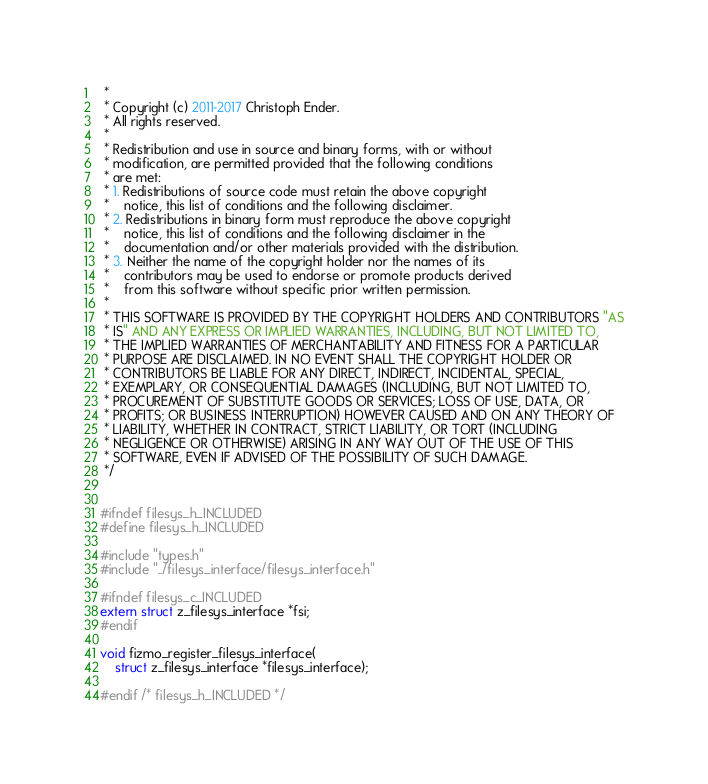Convert code to text. <code><loc_0><loc_0><loc_500><loc_500><_C_> *
 * Copyright (c) 2011-2017 Christoph Ender.
 * All rights reserved.
 *
 * Redistribution and use in source and binary forms, with or without
 * modification, are permitted provided that the following conditions
 * are met:
 * 1. Redistributions of source code must retain the above copyright
 *    notice, this list of conditions and the following disclaimer.
 * 2. Redistributions in binary form must reproduce the above copyright
 *    notice, this list of conditions and the following disclaimer in the
 *    documentation and/or other materials provided with the distribution.
 * 3. Neither the name of the copyright holder nor the names of its
 *    contributors may be used to endorse or promote products derived
 *    from this software without specific prior written permission.
 * 
 * THIS SOFTWARE IS PROVIDED BY THE COPYRIGHT HOLDERS AND CONTRIBUTORS "AS
 * IS" AND ANY EXPRESS OR IMPLIED WARRANTIES, INCLUDING, BUT NOT LIMITED TO,
 * THE IMPLIED WARRANTIES OF MERCHANTABILITY AND FITNESS FOR A PARTICULAR
 * PURPOSE ARE DISCLAIMED. IN NO EVENT SHALL THE COPYRIGHT HOLDER OR
 * CONTRIBUTORS BE LIABLE FOR ANY DIRECT, INDIRECT, INCIDENTAL, SPECIAL,
 * EXEMPLARY, OR CONSEQUENTIAL DAMAGES (INCLUDING, BUT NOT LIMITED TO,
 * PROCUREMENT OF SUBSTITUTE GOODS OR SERVICES; LOSS OF USE, DATA, OR
 * PROFITS; OR BUSINESS INTERRUPTION) HOWEVER CAUSED AND ON ANY THEORY OF
 * LIABILITY, WHETHER IN CONTRACT, STRICT LIABILITY, OR TORT (INCLUDING
 * NEGLIGENCE OR OTHERWISE) ARISING IN ANY WAY OUT OF THE USE OF THIS
 * SOFTWARE, EVEN IF ADVISED OF THE POSSIBILITY OF SUCH DAMAGE.
 */


#ifndef filesys_h_INCLUDED 
#define filesys_h_INCLUDED

#include "types.h"
#include "../filesys_interface/filesys_interface.h"

#ifndef filesys_c_INCLUDED
extern struct z_filesys_interface *fsi;
#endif

void fizmo_register_filesys_interface(
    struct z_filesys_interface *filesys_interface);

#endif /* filesys_h_INCLUDED */

</code> 